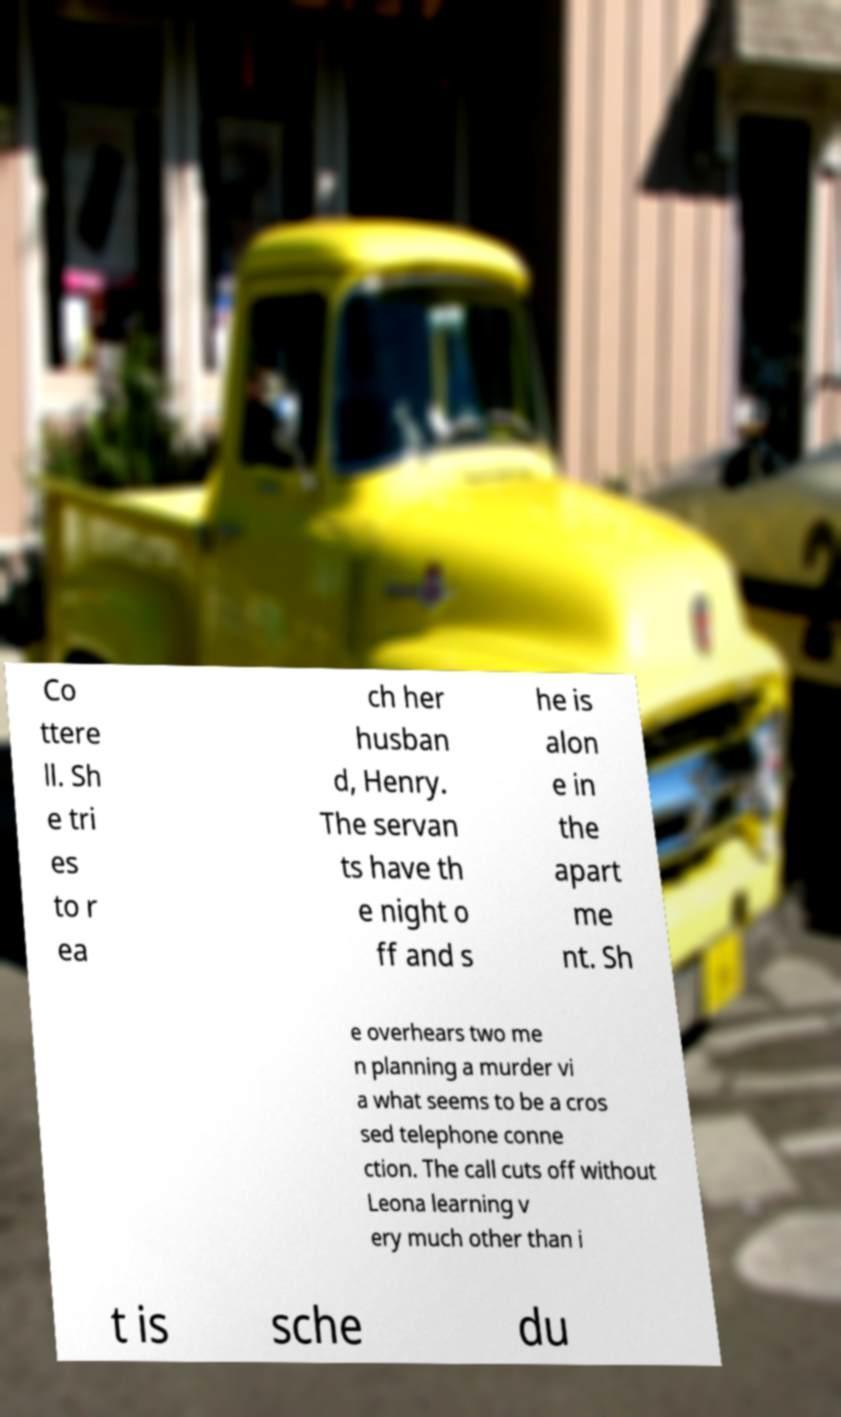What messages or text are displayed in this image? I need them in a readable, typed format. Co ttere ll. Sh e tri es to r ea ch her husban d, Henry. The servan ts have th e night o ff and s he is alon e in the apart me nt. Sh e overhears two me n planning a murder vi a what seems to be a cros sed telephone conne ction. The call cuts off without Leona learning v ery much other than i t is sche du 